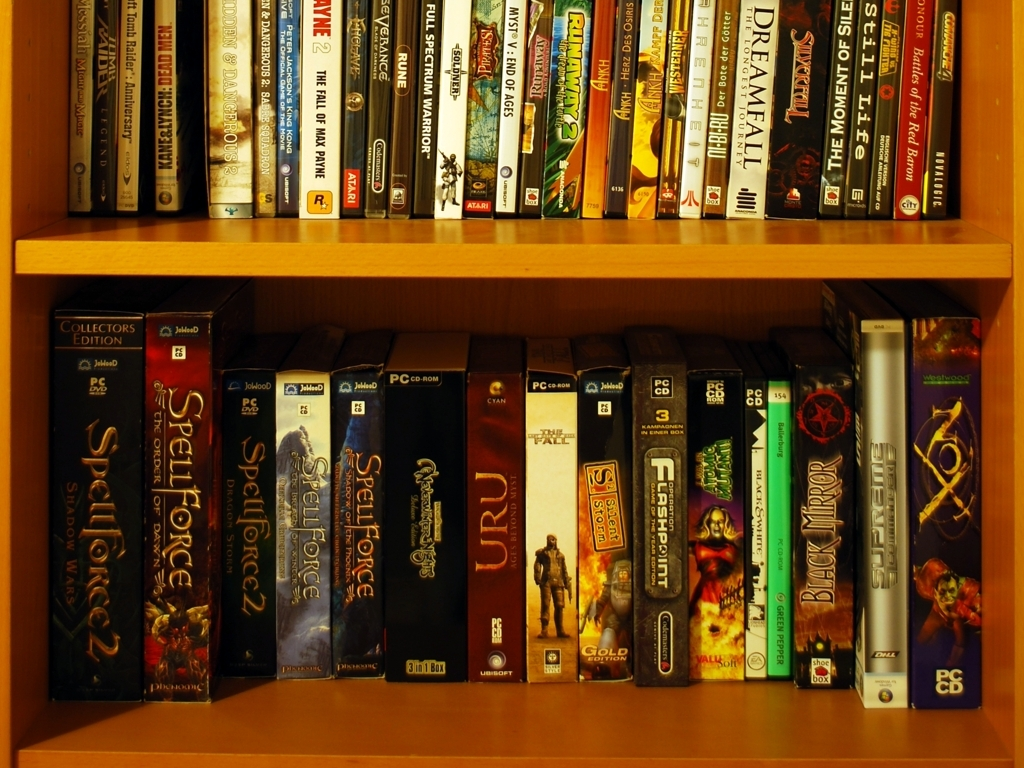Are there any collector's editions or special releases among these games? Yes, indeed. The image shows a box with 'Collector's Edition' labeled on the spine, signifying that this particular game includes special content or items beyond the standard edition. Collectibles like this are often prized by enthusiasts for their limited availability and unique extras. 